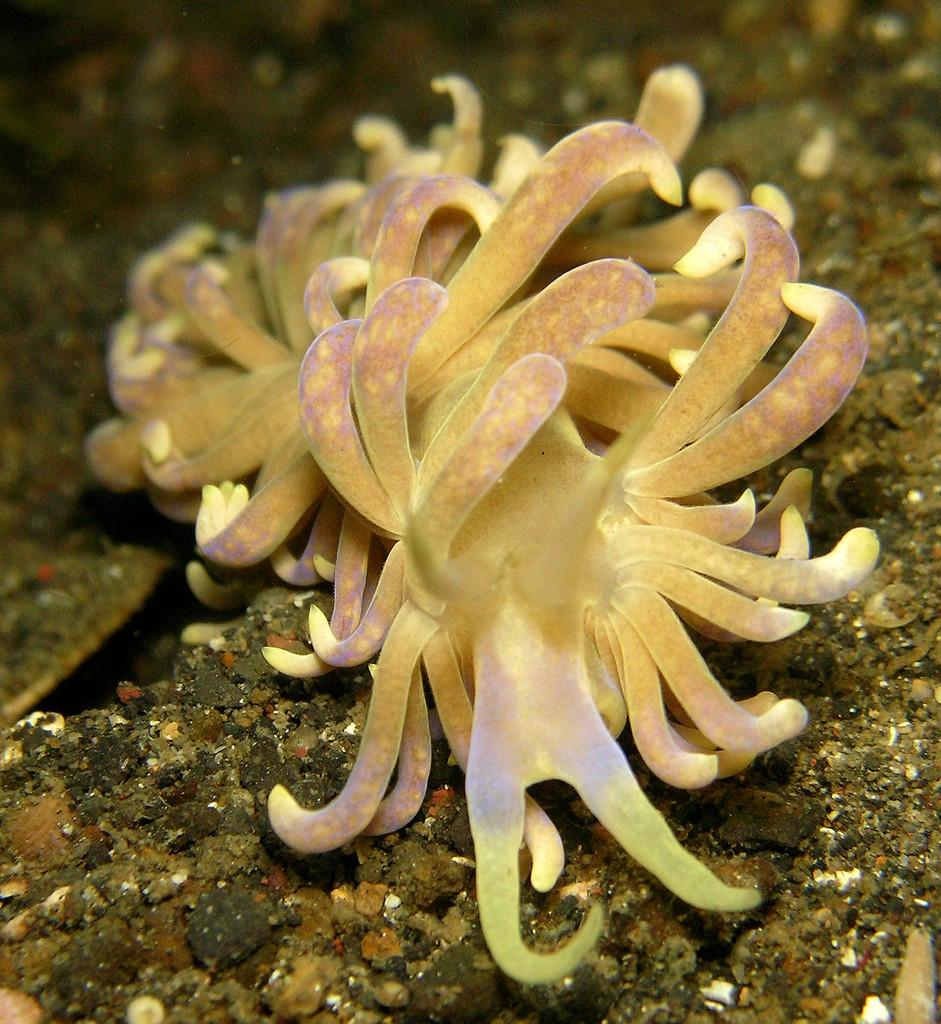Where was the image taken? The image was taken underwater. What types of creatures can be seen in the image? There are marine species visible in the image. What type of pot is being used by the giants in the image? There are no giants or pots present in the image; it features marine species underwater. 